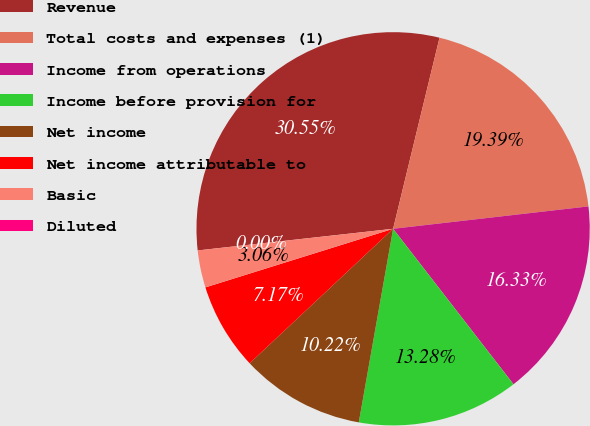Convert chart to OTSL. <chart><loc_0><loc_0><loc_500><loc_500><pie_chart><fcel>Revenue<fcel>Total costs and expenses (1)<fcel>Income from operations<fcel>Income before provision for<fcel>Net income<fcel>Net income attributable to<fcel>Basic<fcel>Diluted<nl><fcel>30.55%<fcel>19.39%<fcel>16.33%<fcel>13.28%<fcel>10.22%<fcel>7.17%<fcel>3.06%<fcel>0.0%<nl></chart> 